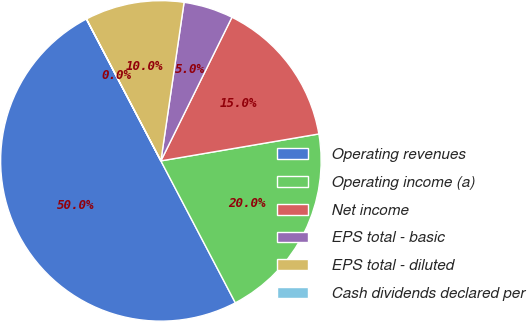Convert chart. <chart><loc_0><loc_0><loc_500><loc_500><pie_chart><fcel>Operating revenues<fcel>Operating income (a)<fcel>Net income<fcel>EPS total - basic<fcel>EPS total - diluted<fcel>Cash dividends declared per<nl><fcel>49.99%<fcel>20.0%<fcel>15.0%<fcel>5.0%<fcel>10.0%<fcel>0.01%<nl></chart> 